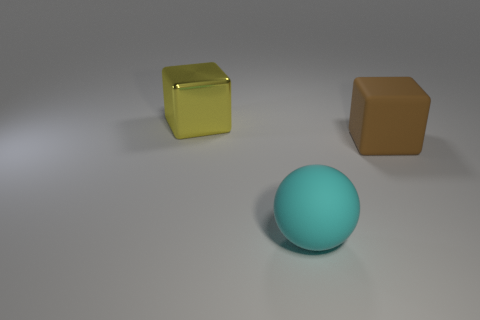Add 3 large brown cubes. How many objects exist? 6 Subtract all balls. How many objects are left? 2 Add 2 spheres. How many spheres exist? 3 Subtract 0 gray cylinders. How many objects are left? 3 Subtract all matte things. Subtract all brown matte blocks. How many objects are left? 0 Add 2 big rubber cubes. How many big rubber cubes are left? 3 